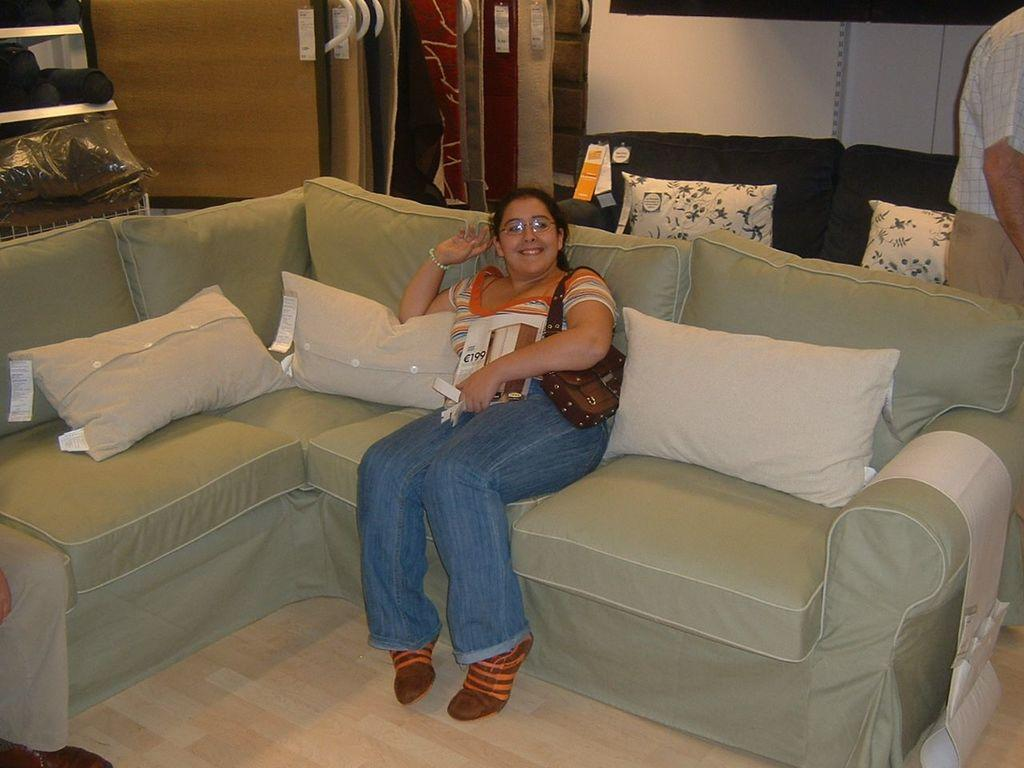Who is present in the image? There is a woman in the image. What is the woman doing in the image? The woman is sitting on a sofa. What can be seen on the sofa in the image? There are pillows on the sofa in the image. What part of the room is visible in the image? The floor is visible in the image. What is visible in the background of the image? There is a wall in the background of the image. What school does the woman attend in the image? There is no indication in the image that the woman attends school, as the image does not show any school-related items or settings. 